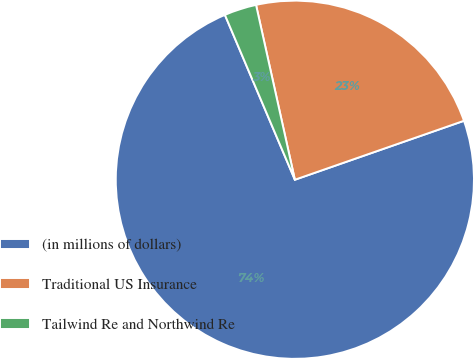<chart> <loc_0><loc_0><loc_500><loc_500><pie_chart><fcel>(in millions of dollars)<fcel>Traditional US Insurance<fcel>Tailwind Re and Northwind Re<nl><fcel>73.95%<fcel>23.14%<fcel>2.91%<nl></chart> 